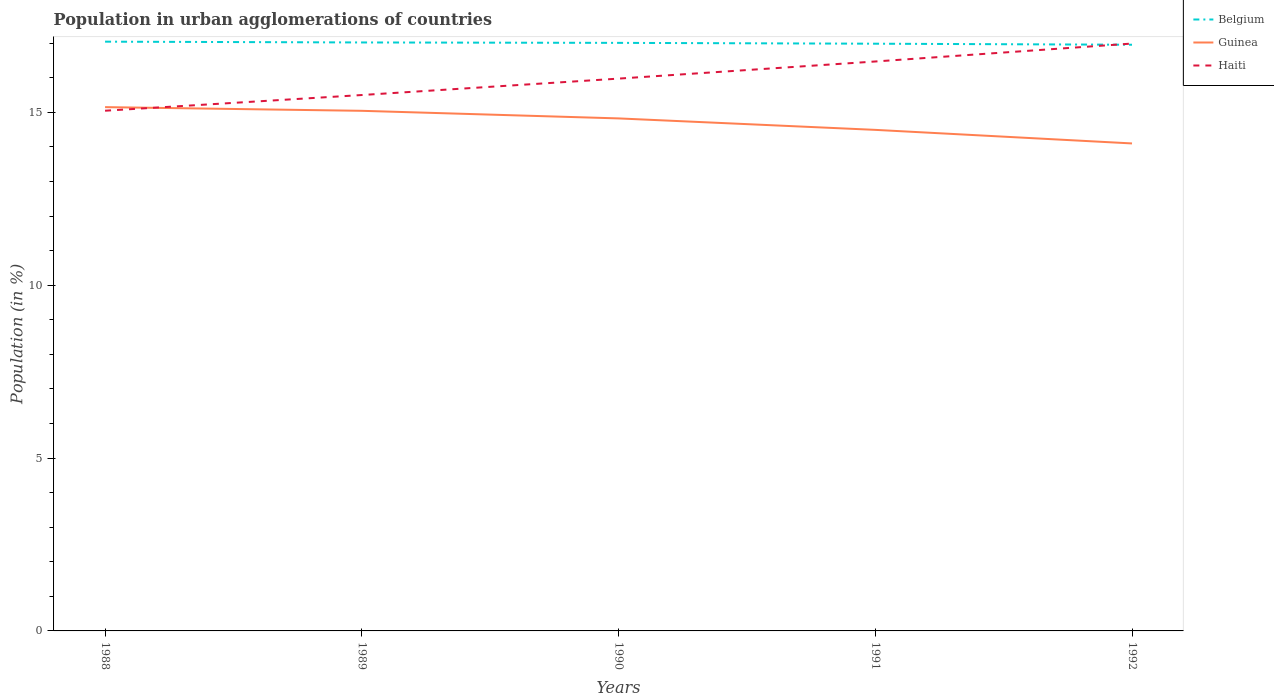How many different coloured lines are there?
Your answer should be compact. 3. Across all years, what is the maximum percentage of population in urban agglomerations in Guinea?
Your answer should be very brief. 14.1. In which year was the percentage of population in urban agglomerations in Belgium maximum?
Provide a short and direct response. 1992. What is the total percentage of population in urban agglomerations in Belgium in the graph?
Offer a terse response. 0.02. What is the difference between the highest and the second highest percentage of population in urban agglomerations in Haiti?
Your answer should be very brief. 1.94. Are the values on the major ticks of Y-axis written in scientific E-notation?
Your response must be concise. No. Where does the legend appear in the graph?
Give a very brief answer. Top right. What is the title of the graph?
Your response must be concise. Population in urban agglomerations of countries. What is the Population (in %) of Belgium in 1988?
Offer a very short reply. 17.05. What is the Population (in %) of Guinea in 1988?
Provide a succinct answer. 15.15. What is the Population (in %) in Haiti in 1988?
Keep it short and to the point. 15.05. What is the Population (in %) in Belgium in 1989?
Keep it short and to the point. 17.02. What is the Population (in %) of Guinea in 1989?
Your response must be concise. 15.04. What is the Population (in %) in Haiti in 1989?
Your answer should be compact. 15.5. What is the Population (in %) in Belgium in 1990?
Make the answer very short. 17.01. What is the Population (in %) in Guinea in 1990?
Your response must be concise. 14.83. What is the Population (in %) in Haiti in 1990?
Your answer should be very brief. 15.98. What is the Population (in %) in Belgium in 1991?
Make the answer very short. 16.99. What is the Population (in %) in Guinea in 1991?
Make the answer very short. 14.49. What is the Population (in %) of Haiti in 1991?
Provide a succinct answer. 16.47. What is the Population (in %) of Belgium in 1992?
Offer a terse response. 16.96. What is the Population (in %) in Guinea in 1992?
Give a very brief answer. 14.1. What is the Population (in %) of Haiti in 1992?
Make the answer very short. 16.99. Across all years, what is the maximum Population (in %) of Belgium?
Your answer should be compact. 17.05. Across all years, what is the maximum Population (in %) in Guinea?
Your response must be concise. 15.15. Across all years, what is the maximum Population (in %) of Haiti?
Give a very brief answer. 16.99. Across all years, what is the minimum Population (in %) in Belgium?
Offer a terse response. 16.96. Across all years, what is the minimum Population (in %) in Guinea?
Provide a succinct answer. 14.1. Across all years, what is the minimum Population (in %) in Haiti?
Offer a very short reply. 15.05. What is the total Population (in %) of Belgium in the graph?
Keep it short and to the point. 85.02. What is the total Population (in %) in Guinea in the graph?
Your answer should be very brief. 73.62. What is the total Population (in %) of Haiti in the graph?
Ensure brevity in your answer.  79.99. What is the difference between the Population (in %) in Belgium in 1988 and that in 1989?
Give a very brief answer. 0.02. What is the difference between the Population (in %) of Guinea in 1988 and that in 1989?
Your answer should be very brief. 0.11. What is the difference between the Population (in %) in Haiti in 1988 and that in 1989?
Offer a terse response. -0.45. What is the difference between the Population (in %) of Belgium in 1988 and that in 1990?
Give a very brief answer. 0.03. What is the difference between the Population (in %) in Guinea in 1988 and that in 1990?
Your answer should be compact. 0.33. What is the difference between the Population (in %) of Haiti in 1988 and that in 1990?
Provide a succinct answer. -0.93. What is the difference between the Population (in %) in Belgium in 1988 and that in 1991?
Offer a very short reply. 0.06. What is the difference between the Population (in %) in Guinea in 1988 and that in 1991?
Offer a terse response. 0.66. What is the difference between the Population (in %) of Haiti in 1988 and that in 1991?
Ensure brevity in your answer.  -1.42. What is the difference between the Population (in %) in Belgium in 1988 and that in 1992?
Your answer should be very brief. 0.09. What is the difference between the Population (in %) of Guinea in 1988 and that in 1992?
Ensure brevity in your answer.  1.05. What is the difference between the Population (in %) in Haiti in 1988 and that in 1992?
Keep it short and to the point. -1.94. What is the difference between the Population (in %) of Belgium in 1989 and that in 1990?
Keep it short and to the point. 0.01. What is the difference between the Population (in %) of Guinea in 1989 and that in 1990?
Offer a very short reply. 0.22. What is the difference between the Population (in %) of Haiti in 1989 and that in 1990?
Offer a very short reply. -0.47. What is the difference between the Population (in %) in Belgium in 1989 and that in 1991?
Ensure brevity in your answer.  0.04. What is the difference between the Population (in %) of Guinea in 1989 and that in 1991?
Offer a very short reply. 0.55. What is the difference between the Population (in %) of Haiti in 1989 and that in 1991?
Keep it short and to the point. -0.97. What is the difference between the Population (in %) of Belgium in 1989 and that in 1992?
Keep it short and to the point. 0.07. What is the difference between the Population (in %) of Guinea in 1989 and that in 1992?
Offer a terse response. 0.94. What is the difference between the Population (in %) of Haiti in 1989 and that in 1992?
Your answer should be compact. -1.49. What is the difference between the Population (in %) of Belgium in 1990 and that in 1991?
Keep it short and to the point. 0.02. What is the difference between the Population (in %) of Guinea in 1990 and that in 1991?
Your answer should be compact. 0.33. What is the difference between the Population (in %) in Haiti in 1990 and that in 1991?
Offer a very short reply. -0.5. What is the difference between the Population (in %) of Belgium in 1990 and that in 1992?
Provide a short and direct response. 0.05. What is the difference between the Population (in %) of Guinea in 1990 and that in 1992?
Your answer should be very brief. 0.72. What is the difference between the Population (in %) in Haiti in 1990 and that in 1992?
Provide a succinct answer. -1.01. What is the difference between the Population (in %) in Guinea in 1991 and that in 1992?
Your response must be concise. 0.39. What is the difference between the Population (in %) in Haiti in 1991 and that in 1992?
Provide a short and direct response. -0.52. What is the difference between the Population (in %) in Belgium in 1988 and the Population (in %) in Guinea in 1989?
Provide a short and direct response. 2. What is the difference between the Population (in %) of Belgium in 1988 and the Population (in %) of Haiti in 1989?
Provide a succinct answer. 1.54. What is the difference between the Population (in %) of Guinea in 1988 and the Population (in %) of Haiti in 1989?
Ensure brevity in your answer.  -0.35. What is the difference between the Population (in %) in Belgium in 1988 and the Population (in %) in Guinea in 1990?
Make the answer very short. 2.22. What is the difference between the Population (in %) in Belgium in 1988 and the Population (in %) in Haiti in 1990?
Your answer should be very brief. 1.07. What is the difference between the Population (in %) of Guinea in 1988 and the Population (in %) of Haiti in 1990?
Make the answer very short. -0.82. What is the difference between the Population (in %) of Belgium in 1988 and the Population (in %) of Guinea in 1991?
Offer a terse response. 2.55. What is the difference between the Population (in %) in Belgium in 1988 and the Population (in %) in Haiti in 1991?
Your answer should be very brief. 0.57. What is the difference between the Population (in %) in Guinea in 1988 and the Population (in %) in Haiti in 1991?
Your answer should be compact. -1.32. What is the difference between the Population (in %) of Belgium in 1988 and the Population (in %) of Guinea in 1992?
Offer a terse response. 2.94. What is the difference between the Population (in %) of Belgium in 1988 and the Population (in %) of Haiti in 1992?
Provide a short and direct response. 0.05. What is the difference between the Population (in %) in Guinea in 1988 and the Population (in %) in Haiti in 1992?
Provide a short and direct response. -1.84. What is the difference between the Population (in %) in Belgium in 1989 and the Population (in %) in Guinea in 1990?
Make the answer very short. 2.2. What is the difference between the Population (in %) in Belgium in 1989 and the Population (in %) in Haiti in 1990?
Provide a succinct answer. 1.05. What is the difference between the Population (in %) of Guinea in 1989 and the Population (in %) of Haiti in 1990?
Your answer should be compact. -0.93. What is the difference between the Population (in %) in Belgium in 1989 and the Population (in %) in Guinea in 1991?
Provide a succinct answer. 2.53. What is the difference between the Population (in %) of Belgium in 1989 and the Population (in %) of Haiti in 1991?
Offer a terse response. 0.55. What is the difference between the Population (in %) of Guinea in 1989 and the Population (in %) of Haiti in 1991?
Give a very brief answer. -1.43. What is the difference between the Population (in %) of Belgium in 1989 and the Population (in %) of Guinea in 1992?
Offer a terse response. 2.92. What is the difference between the Population (in %) of Belgium in 1989 and the Population (in %) of Haiti in 1992?
Give a very brief answer. 0.03. What is the difference between the Population (in %) of Guinea in 1989 and the Population (in %) of Haiti in 1992?
Your answer should be compact. -1.95. What is the difference between the Population (in %) of Belgium in 1990 and the Population (in %) of Guinea in 1991?
Give a very brief answer. 2.52. What is the difference between the Population (in %) in Belgium in 1990 and the Population (in %) in Haiti in 1991?
Provide a succinct answer. 0.54. What is the difference between the Population (in %) in Guinea in 1990 and the Population (in %) in Haiti in 1991?
Your answer should be compact. -1.65. What is the difference between the Population (in %) in Belgium in 1990 and the Population (in %) in Guinea in 1992?
Keep it short and to the point. 2.91. What is the difference between the Population (in %) in Belgium in 1990 and the Population (in %) in Haiti in 1992?
Your answer should be very brief. 0.02. What is the difference between the Population (in %) of Guinea in 1990 and the Population (in %) of Haiti in 1992?
Make the answer very short. -2.17. What is the difference between the Population (in %) of Belgium in 1991 and the Population (in %) of Guinea in 1992?
Offer a very short reply. 2.88. What is the difference between the Population (in %) of Belgium in 1991 and the Population (in %) of Haiti in 1992?
Make the answer very short. -0. What is the difference between the Population (in %) of Guinea in 1991 and the Population (in %) of Haiti in 1992?
Keep it short and to the point. -2.5. What is the average Population (in %) in Belgium per year?
Provide a short and direct response. 17. What is the average Population (in %) in Guinea per year?
Offer a terse response. 14.72. What is the average Population (in %) in Haiti per year?
Make the answer very short. 16. In the year 1988, what is the difference between the Population (in %) of Belgium and Population (in %) of Guinea?
Provide a short and direct response. 1.89. In the year 1988, what is the difference between the Population (in %) of Belgium and Population (in %) of Haiti?
Provide a short and direct response. 2. In the year 1988, what is the difference between the Population (in %) of Guinea and Population (in %) of Haiti?
Your response must be concise. 0.1. In the year 1989, what is the difference between the Population (in %) of Belgium and Population (in %) of Guinea?
Your answer should be very brief. 1.98. In the year 1989, what is the difference between the Population (in %) in Belgium and Population (in %) in Haiti?
Offer a terse response. 1.52. In the year 1989, what is the difference between the Population (in %) in Guinea and Population (in %) in Haiti?
Your response must be concise. -0.46. In the year 1990, what is the difference between the Population (in %) of Belgium and Population (in %) of Guinea?
Your answer should be compact. 2.19. In the year 1990, what is the difference between the Population (in %) of Belgium and Population (in %) of Haiti?
Provide a short and direct response. 1.03. In the year 1990, what is the difference between the Population (in %) in Guinea and Population (in %) in Haiti?
Offer a terse response. -1.15. In the year 1991, what is the difference between the Population (in %) in Belgium and Population (in %) in Guinea?
Offer a very short reply. 2.49. In the year 1991, what is the difference between the Population (in %) in Belgium and Population (in %) in Haiti?
Ensure brevity in your answer.  0.51. In the year 1991, what is the difference between the Population (in %) of Guinea and Population (in %) of Haiti?
Make the answer very short. -1.98. In the year 1992, what is the difference between the Population (in %) of Belgium and Population (in %) of Guinea?
Ensure brevity in your answer.  2.85. In the year 1992, what is the difference between the Population (in %) of Belgium and Population (in %) of Haiti?
Provide a short and direct response. -0.03. In the year 1992, what is the difference between the Population (in %) in Guinea and Population (in %) in Haiti?
Offer a terse response. -2.89. What is the ratio of the Population (in %) of Belgium in 1988 to that in 1989?
Provide a short and direct response. 1. What is the ratio of the Population (in %) of Guinea in 1988 to that in 1989?
Your answer should be very brief. 1.01. What is the ratio of the Population (in %) in Haiti in 1988 to that in 1989?
Offer a terse response. 0.97. What is the ratio of the Population (in %) in Guinea in 1988 to that in 1990?
Provide a short and direct response. 1.02. What is the ratio of the Population (in %) in Haiti in 1988 to that in 1990?
Offer a terse response. 0.94. What is the ratio of the Population (in %) in Belgium in 1988 to that in 1991?
Give a very brief answer. 1. What is the ratio of the Population (in %) of Guinea in 1988 to that in 1991?
Provide a short and direct response. 1.05. What is the ratio of the Population (in %) of Haiti in 1988 to that in 1991?
Keep it short and to the point. 0.91. What is the ratio of the Population (in %) in Belgium in 1988 to that in 1992?
Ensure brevity in your answer.  1.01. What is the ratio of the Population (in %) of Guinea in 1988 to that in 1992?
Your answer should be compact. 1.07. What is the ratio of the Population (in %) of Haiti in 1988 to that in 1992?
Your response must be concise. 0.89. What is the ratio of the Population (in %) in Guinea in 1989 to that in 1990?
Make the answer very short. 1.01. What is the ratio of the Population (in %) of Haiti in 1989 to that in 1990?
Offer a very short reply. 0.97. What is the ratio of the Population (in %) of Guinea in 1989 to that in 1991?
Offer a terse response. 1.04. What is the ratio of the Population (in %) in Haiti in 1989 to that in 1991?
Your response must be concise. 0.94. What is the ratio of the Population (in %) in Belgium in 1989 to that in 1992?
Your answer should be very brief. 1. What is the ratio of the Population (in %) of Guinea in 1989 to that in 1992?
Offer a very short reply. 1.07. What is the ratio of the Population (in %) in Haiti in 1989 to that in 1992?
Provide a succinct answer. 0.91. What is the ratio of the Population (in %) of Guinea in 1990 to that in 1991?
Offer a very short reply. 1.02. What is the ratio of the Population (in %) in Haiti in 1990 to that in 1991?
Offer a terse response. 0.97. What is the ratio of the Population (in %) of Guinea in 1990 to that in 1992?
Ensure brevity in your answer.  1.05. What is the ratio of the Population (in %) in Haiti in 1990 to that in 1992?
Make the answer very short. 0.94. What is the ratio of the Population (in %) of Guinea in 1991 to that in 1992?
Your answer should be very brief. 1.03. What is the ratio of the Population (in %) of Haiti in 1991 to that in 1992?
Make the answer very short. 0.97. What is the difference between the highest and the second highest Population (in %) in Belgium?
Offer a very short reply. 0.02. What is the difference between the highest and the second highest Population (in %) of Guinea?
Make the answer very short. 0.11. What is the difference between the highest and the second highest Population (in %) of Haiti?
Your answer should be compact. 0.52. What is the difference between the highest and the lowest Population (in %) in Belgium?
Your answer should be compact. 0.09. What is the difference between the highest and the lowest Population (in %) of Guinea?
Keep it short and to the point. 1.05. What is the difference between the highest and the lowest Population (in %) in Haiti?
Make the answer very short. 1.94. 